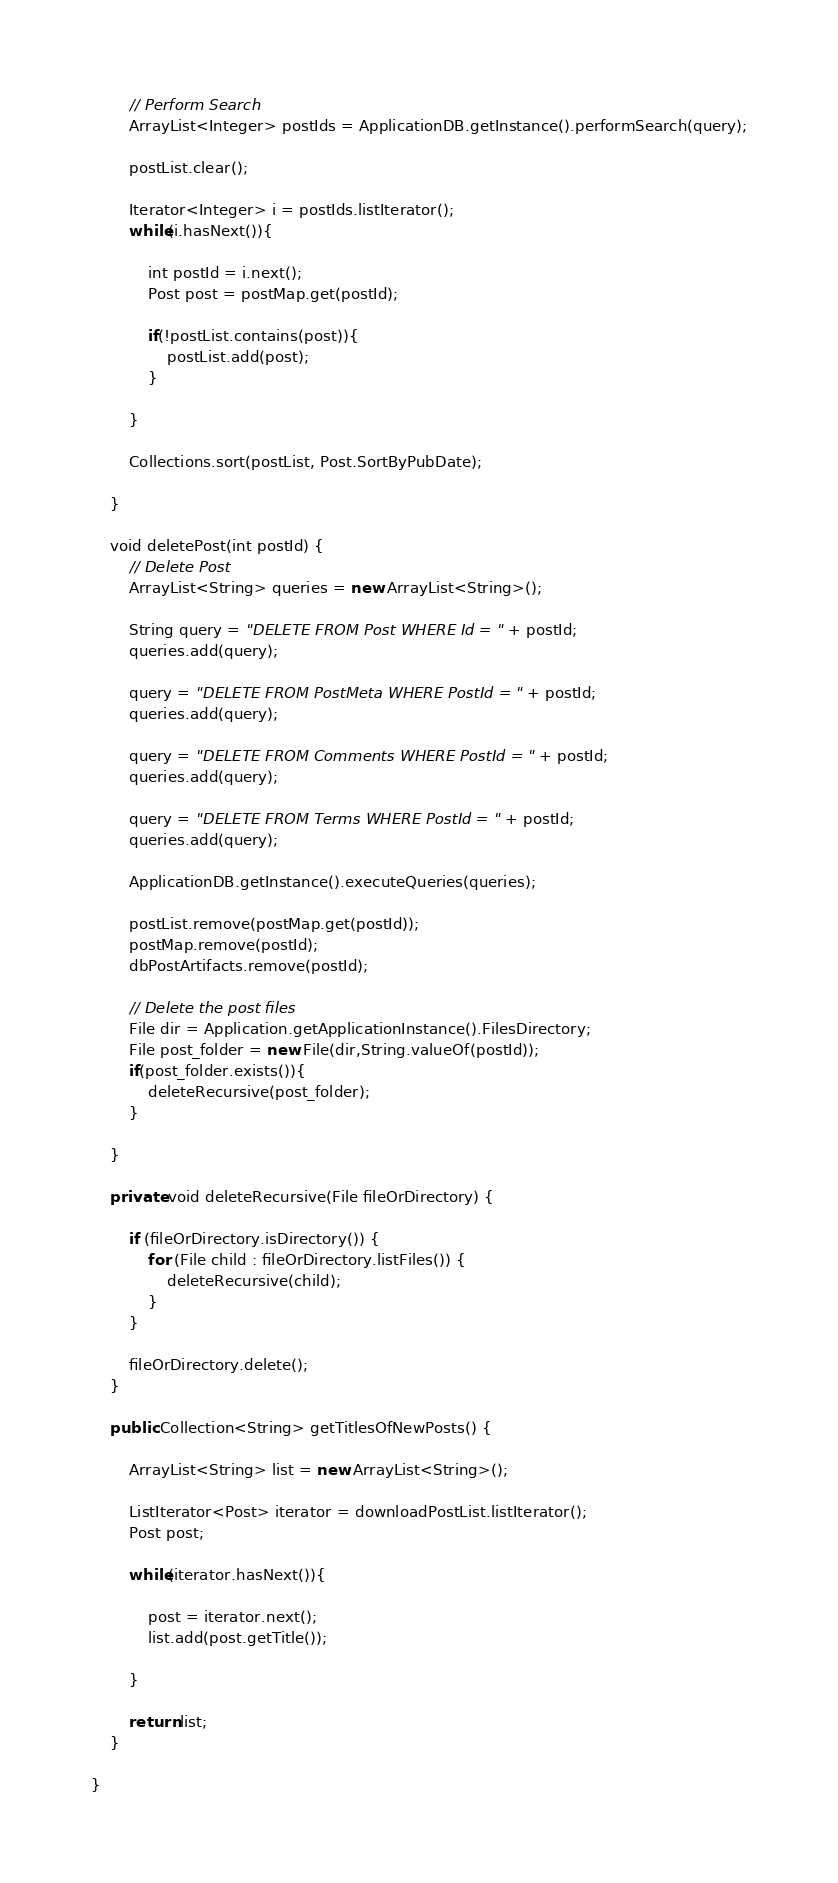Convert code to text. <code><loc_0><loc_0><loc_500><loc_500><_Java_>		// Perform Search
		ArrayList<Integer> postIds = ApplicationDB.getInstance().performSearch(query);
		
		postList.clear();
		
		Iterator<Integer> i = postIds.listIterator();
		while(i.hasNext()){
			
			int postId = i.next();
			Post post = postMap.get(postId);
			
			if(!postList.contains(post)){
				postList.add(post);
			}
			
		}
		
		Collections.sort(postList, Post.SortByPubDate);
		
	}

	void deletePost(int postId) {
		// Delete Post
		ArrayList<String> queries = new ArrayList<String>();
		
		String query = "DELETE FROM Post WHERE Id = " + postId;
		queries.add(query);
		
		query = "DELETE FROM PostMeta WHERE PostId = " + postId;
		queries.add(query);
		
		query = "DELETE FROM Comments WHERE PostId = " + postId;
		queries.add(query);
		
		query = "DELETE FROM Terms WHERE PostId = " + postId;
		queries.add(query);
		
		ApplicationDB.getInstance().executeQueries(queries);
		
		postList.remove(postMap.get(postId));
		postMap.remove(postId);
		dbPostArtifacts.remove(postId);

		// Delete the post files
		File dir = Application.getApplicationInstance().FilesDirectory;
		File post_folder = new File(dir,String.valueOf(postId));
		if(post_folder.exists()){
			deleteRecursive(post_folder);
		}

	}

	private void deleteRecursive(File fileOrDirectory) {

		if (fileOrDirectory.isDirectory()) {
			for (File child : fileOrDirectory.listFiles()) {
				deleteRecursive(child);
			}
		}

		fileOrDirectory.delete();
	}

	public Collection<String> getTitlesOfNewPosts() {
		
		ArrayList<String> list = new ArrayList<String>();
		
		ListIterator<Post> iterator = downloadPostList.listIterator();
		Post post;
		
		while(iterator.hasNext()){
			
			post = iterator.next();
			list.add(post.getTitle());
			
		}
		
		return list;
	}
	
}</code> 